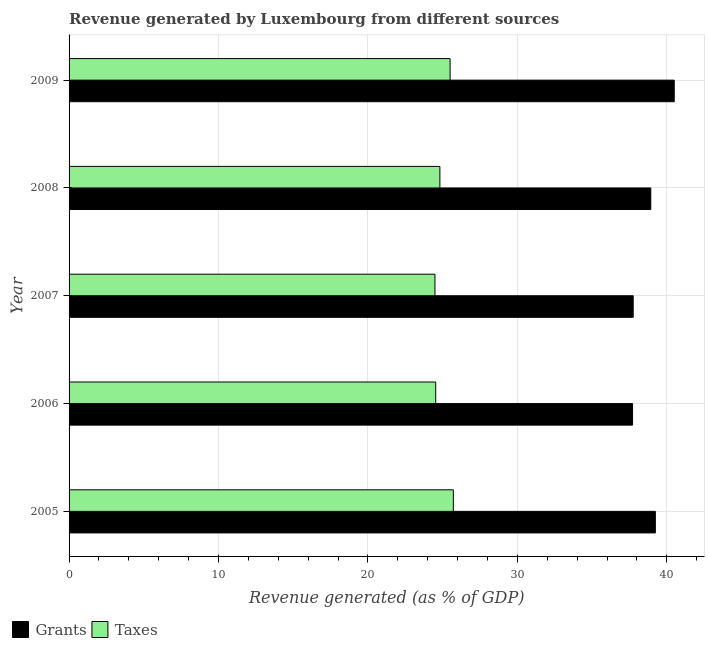Are the number of bars per tick equal to the number of legend labels?
Your response must be concise. Yes. Are the number of bars on each tick of the Y-axis equal?
Offer a terse response. Yes. How many bars are there on the 1st tick from the top?
Ensure brevity in your answer.  2. How many bars are there on the 5th tick from the bottom?
Make the answer very short. 2. What is the label of the 2nd group of bars from the top?
Provide a short and direct response. 2008. In how many cases, is the number of bars for a given year not equal to the number of legend labels?
Your answer should be very brief. 0. What is the revenue generated by taxes in 2008?
Offer a terse response. 24.81. Across all years, what is the maximum revenue generated by taxes?
Offer a very short reply. 25.71. Across all years, what is the minimum revenue generated by taxes?
Offer a very short reply. 24.48. In which year was the revenue generated by grants maximum?
Your response must be concise. 2009. In which year was the revenue generated by taxes minimum?
Provide a short and direct response. 2007. What is the total revenue generated by grants in the graph?
Keep it short and to the point. 194.11. What is the difference between the revenue generated by taxes in 2008 and that in 2009?
Keep it short and to the point. -0.68. What is the difference between the revenue generated by grants in 2009 and the revenue generated by taxes in 2008?
Your answer should be compact. 15.68. What is the average revenue generated by taxes per year?
Offer a terse response. 25.01. In the year 2005, what is the difference between the revenue generated by grants and revenue generated by taxes?
Ensure brevity in your answer.  13.52. In how many years, is the revenue generated by taxes greater than 18 %?
Provide a short and direct response. 5. What is the difference between the highest and the second highest revenue generated by grants?
Provide a short and direct response. 1.26. What is the difference between the highest and the lowest revenue generated by grants?
Provide a succinct answer. 2.79. What does the 2nd bar from the top in 2006 represents?
Your answer should be compact. Grants. What does the 2nd bar from the bottom in 2006 represents?
Your response must be concise. Taxes. How many bars are there?
Ensure brevity in your answer.  10. Are the values on the major ticks of X-axis written in scientific E-notation?
Your response must be concise. No. Does the graph contain any zero values?
Your response must be concise. No. Where does the legend appear in the graph?
Provide a succinct answer. Bottom left. What is the title of the graph?
Provide a succinct answer. Revenue generated by Luxembourg from different sources. Does "Electricity and heat production" appear as one of the legend labels in the graph?
Give a very brief answer. No. What is the label or title of the X-axis?
Offer a very short reply. Revenue generated (as % of GDP). What is the label or title of the Y-axis?
Provide a succinct answer. Year. What is the Revenue generated (as % of GDP) of Grants in 2005?
Provide a succinct answer. 39.23. What is the Revenue generated (as % of GDP) in Taxes in 2005?
Offer a terse response. 25.71. What is the Revenue generated (as % of GDP) of Grants in 2006?
Keep it short and to the point. 37.71. What is the Revenue generated (as % of GDP) of Taxes in 2006?
Your answer should be very brief. 24.53. What is the Revenue generated (as % of GDP) of Grants in 2007?
Your response must be concise. 37.75. What is the Revenue generated (as % of GDP) of Taxes in 2007?
Give a very brief answer. 24.48. What is the Revenue generated (as % of GDP) in Grants in 2008?
Make the answer very short. 38.93. What is the Revenue generated (as % of GDP) of Taxes in 2008?
Your response must be concise. 24.81. What is the Revenue generated (as % of GDP) of Grants in 2009?
Your answer should be compact. 40.5. What is the Revenue generated (as % of GDP) of Taxes in 2009?
Keep it short and to the point. 25.5. Across all years, what is the maximum Revenue generated (as % of GDP) in Grants?
Offer a very short reply. 40.5. Across all years, what is the maximum Revenue generated (as % of GDP) in Taxes?
Ensure brevity in your answer.  25.71. Across all years, what is the minimum Revenue generated (as % of GDP) of Grants?
Your response must be concise. 37.71. Across all years, what is the minimum Revenue generated (as % of GDP) in Taxes?
Keep it short and to the point. 24.48. What is the total Revenue generated (as % of GDP) in Grants in the graph?
Your answer should be compact. 194.11. What is the total Revenue generated (as % of GDP) in Taxes in the graph?
Offer a terse response. 125.04. What is the difference between the Revenue generated (as % of GDP) in Grants in 2005 and that in 2006?
Ensure brevity in your answer.  1.53. What is the difference between the Revenue generated (as % of GDP) in Taxes in 2005 and that in 2006?
Offer a very short reply. 1.18. What is the difference between the Revenue generated (as % of GDP) in Grants in 2005 and that in 2007?
Give a very brief answer. 1.48. What is the difference between the Revenue generated (as % of GDP) of Taxes in 2005 and that in 2007?
Your answer should be compact. 1.23. What is the difference between the Revenue generated (as % of GDP) in Grants in 2005 and that in 2008?
Offer a very short reply. 0.31. What is the difference between the Revenue generated (as % of GDP) of Taxes in 2005 and that in 2008?
Provide a short and direct response. 0.9. What is the difference between the Revenue generated (as % of GDP) in Grants in 2005 and that in 2009?
Offer a terse response. -1.26. What is the difference between the Revenue generated (as % of GDP) in Taxes in 2005 and that in 2009?
Ensure brevity in your answer.  0.22. What is the difference between the Revenue generated (as % of GDP) of Grants in 2006 and that in 2007?
Ensure brevity in your answer.  -0.04. What is the difference between the Revenue generated (as % of GDP) of Taxes in 2006 and that in 2007?
Offer a very short reply. 0.05. What is the difference between the Revenue generated (as % of GDP) in Grants in 2006 and that in 2008?
Provide a short and direct response. -1.22. What is the difference between the Revenue generated (as % of GDP) in Taxes in 2006 and that in 2008?
Offer a terse response. -0.28. What is the difference between the Revenue generated (as % of GDP) in Grants in 2006 and that in 2009?
Provide a short and direct response. -2.79. What is the difference between the Revenue generated (as % of GDP) in Taxes in 2006 and that in 2009?
Ensure brevity in your answer.  -0.96. What is the difference between the Revenue generated (as % of GDP) of Grants in 2007 and that in 2008?
Ensure brevity in your answer.  -1.18. What is the difference between the Revenue generated (as % of GDP) of Taxes in 2007 and that in 2008?
Offer a very short reply. -0.33. What is the difference between the Revenue generated (as % of GDP) of Grants in 2007 and that in 2009?
Ensure brevity in your answer.  -2.75. What is the difference between the Revenue generated (as % of GDP) of Taxes in 2007 and that in 2009?
Your answer should be very brief. -1.01. What is the difference between the Revenue generated (as % of GDP) of Grants in 2008 and that in 2009?
Give a very brief answer. -1.57. What is the difference between the Revenue generated (as % of GDP) in Taxes in 2008 and that in 2009?
Offer a very short reply. -0.68. What is the difference between the Revenue generated (as % of GDP) in Grants in 2005 and the Revenue generated (as % of GDP) in Taxes in 2006?
Offer a very short reply. 14.7. What is the difference between the Revenue generated (as % of GDP) in Grants in 2005 and the Revenue generated (as % of GDP) in Taxes in 2007?
Your answer should be very brief. 14.75. What is the difference between the Revenue generated (as % of GDP) of Grants in 2005 and the Revenue generated (as % of GDP) of Taxes in 2008?
Ensure brevity in your answer.  14.42. What is the difference between the Revenue generated (as % of GDP) in Grants in 2005 and the Revenue generated (as % of GDP) in Taxes in 2009?
Offer a very short reply. 13.74. What is the difference between the Revenue generated (as % of GDP) in Grants in 2006 and the Revenue generated (as % of GDP) in Taxes in 2007?
Give a very brief answer. 13.22. What is the difference between the Revenue generated (as % of GDP) in Grants in 2006 and the Revenue generated (as % of GDP) in Taxes in 2008?
Provide a short and direct response. 12.89. What is the difference between the Revenue generated (as % of GDP) in Grants in 2006 and the Revenue generated (as % of GDP) in Taxes in 2009?
Provide a succinct answer. 12.21. What is the difference between the Revenue generated (as % of GDP) of Grants in 2007 and the Revenue generated (as % of GDP) of Taxes in 2008?
Give a very brief answer. 12.93. What is the difference between the Revenue generated (as % of GDP) in Grants in 2007 and the Revenue generated (as % of GDP) in Taxes in 2009?
Ensure brevity in your answer.  12.25. What is the difference between the Revenue generated (as % of GDP) of Grants in 2008 and the Revenue generated (as % of GDP) of Taxes in 2009?
Your answer should be compact. 13.43. What is the average Revenue generated (as % of GDP) in Grants per year?
Give a very brief answer. 38.82. What is the average Revenue generated (as % of GDP) in Taxes per year?
Offer a very short reply. 25.01. In the year 2005, what is the difference between the Revenue generated (as % of GDP) of Grants and Revenue generated (as % of GDP) of Taxes?
Provide a succinct answer. 13.52. In the year 2006, what is the difference between the Revenue generated (as % of GDP) in Grants and Revenue generated (as % of GDP) in Taxes?
Your answer should be very brief. 13.17. In the year 2007, what is the difference between the Revenue generated (as % of GDP) of Grants and Revenue generated (as % of GDP) of Taxes?
Offer a terse response. 13.26. In the year 2008, what is the difference between the Revenue generated (as % of GDP) of Grants and Revenue generated (as % of GDP) of Taxes?
Your answer should be very brief. 14.11. In the year 2009, what is the difference between the Revenue generated (as % of GDP) of Grants and Revenue generated (as % of GDP) of Taxes?
Make the answer very short. 15. What is the ratio of the Revenue generated (as % of GDP) of Grants in 2005 to that in 2006?
Ensure brevity in your answer.  1.04. What is the ratio of the Revenue generated (as % of GDP) in Taxes in 2005 to that in 2006?
Provide a succinct answer. 1.05. What is the ratio of the Revenue generated (as % of GDP) of Grants in 2005 to that in 2007?
Your answer should be compact. 1.04. What is the ratio of the Revenue generated (as % of GDP) in Taxes in 2005 to that in 2007?
Give a very brief answer. 1.05. What is the ratio of the Revenue generated (as % of GDP) of Grants in 2005 to that in 2008?
Ensure brevity in your answer.  1.01. What is the ratio of the Revenue generated (as % of GDP) in Taxes in 2005 to that in 2008?
Your answer should be very brief. 1.04. What is the ratio of the Revenue generated (as % of GDP) of Grants in 2005 to that in 2009?
Provide a succinct answer. 0.97. What is the ratio of the Revenue generated (as % of GDP) of Taxes in 2005 to that in 2009?
Give a very brief answer. 1.01. What is the ratio of the Revenue generated (as % of GDP) in Taxes in 2006 to that in 2007?
Give a very brief answer. 1. What is the ratio of the Revenue generated (as % of GDP) in Grants in 2006 to that in 2008?
Make the answer very short. 0.97. What is the ratio of the Revenue generated (as % of GDP) of Taxes in 2006 to that in 2008?
Your response must be concise. 0.99. What is the ratio of the Revenue generated (as % of GDP) in Grants in 2006 to that in 2009?
Make the answer very short. 0.93. What is the ratio of the Revenue generated (as % of GDP) in Taxes in 2006 to that in 2009?
Provide a succinct answer. 0.96. What is the ratio of the Revenue generated (as % of GDP) of Grants in 2007 to that in 2008?
Provide a short and direct response. 0.97. What is the ratio of the Revenue generated (as % of GDP) of Taxes in 2007 to that in 2008?
Provide a succinct answer. 0.99. What is the ratio of the Revenue generated (as % of GDP) of Grants in 2007 to that in 2009?
Make the answer very short. 0.93. What is the ratio of the Revenue generated (as % of GDP) in Taxes in 2007 to that in 2009?
Keep it short and to the point. 0.96. What is the ratio of the Revenue generated (as % of GDP) in Grants in 2008 to that in 2009?
Ensure brevity in your answer.  0.96. What is the ratio of the Revenue generated (as % of GDP) in Taxes in 2008 to that in 2009?
Keep it short and to the point. 0.97. What is the difference between the highest and the second highest Revenue generated (as % of GDP) in Grants?
Keep it short and to the point. 1.26. What is the difference between the highest and the second highest Revenue generated (as % of GDP) in Taxes?
Offer a very short reply. 0.22. What is the difference between the highest and the lowest Revenue generated (as % of GDP) of Grants?
Provide a succinct answer. 2.79. What is the difference between the highest and the lowest Revenue generated (as % of GDP) of Taxes?
Your answer should be very brief. 1.23. 